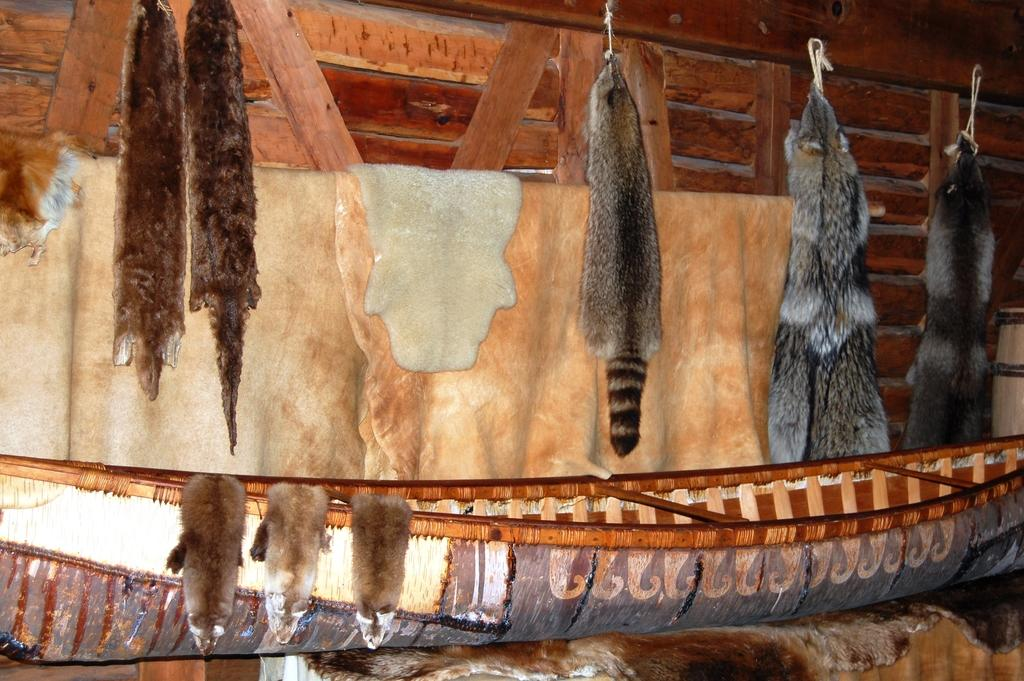What is the main subject of the image? The main subject of the image is a boat. What materials are used in the image? Animal skins and a wooden wall are present in the image. How many girls are standing on the boat in the image? There are no girls present in the image; it only features a boat, animal skins, and a wooden wall. What color is the toe of the animal skin in the image? There is no mention of a toe or any specific color in the image, as it only features a boat, animal skins, and a wooden wall. 